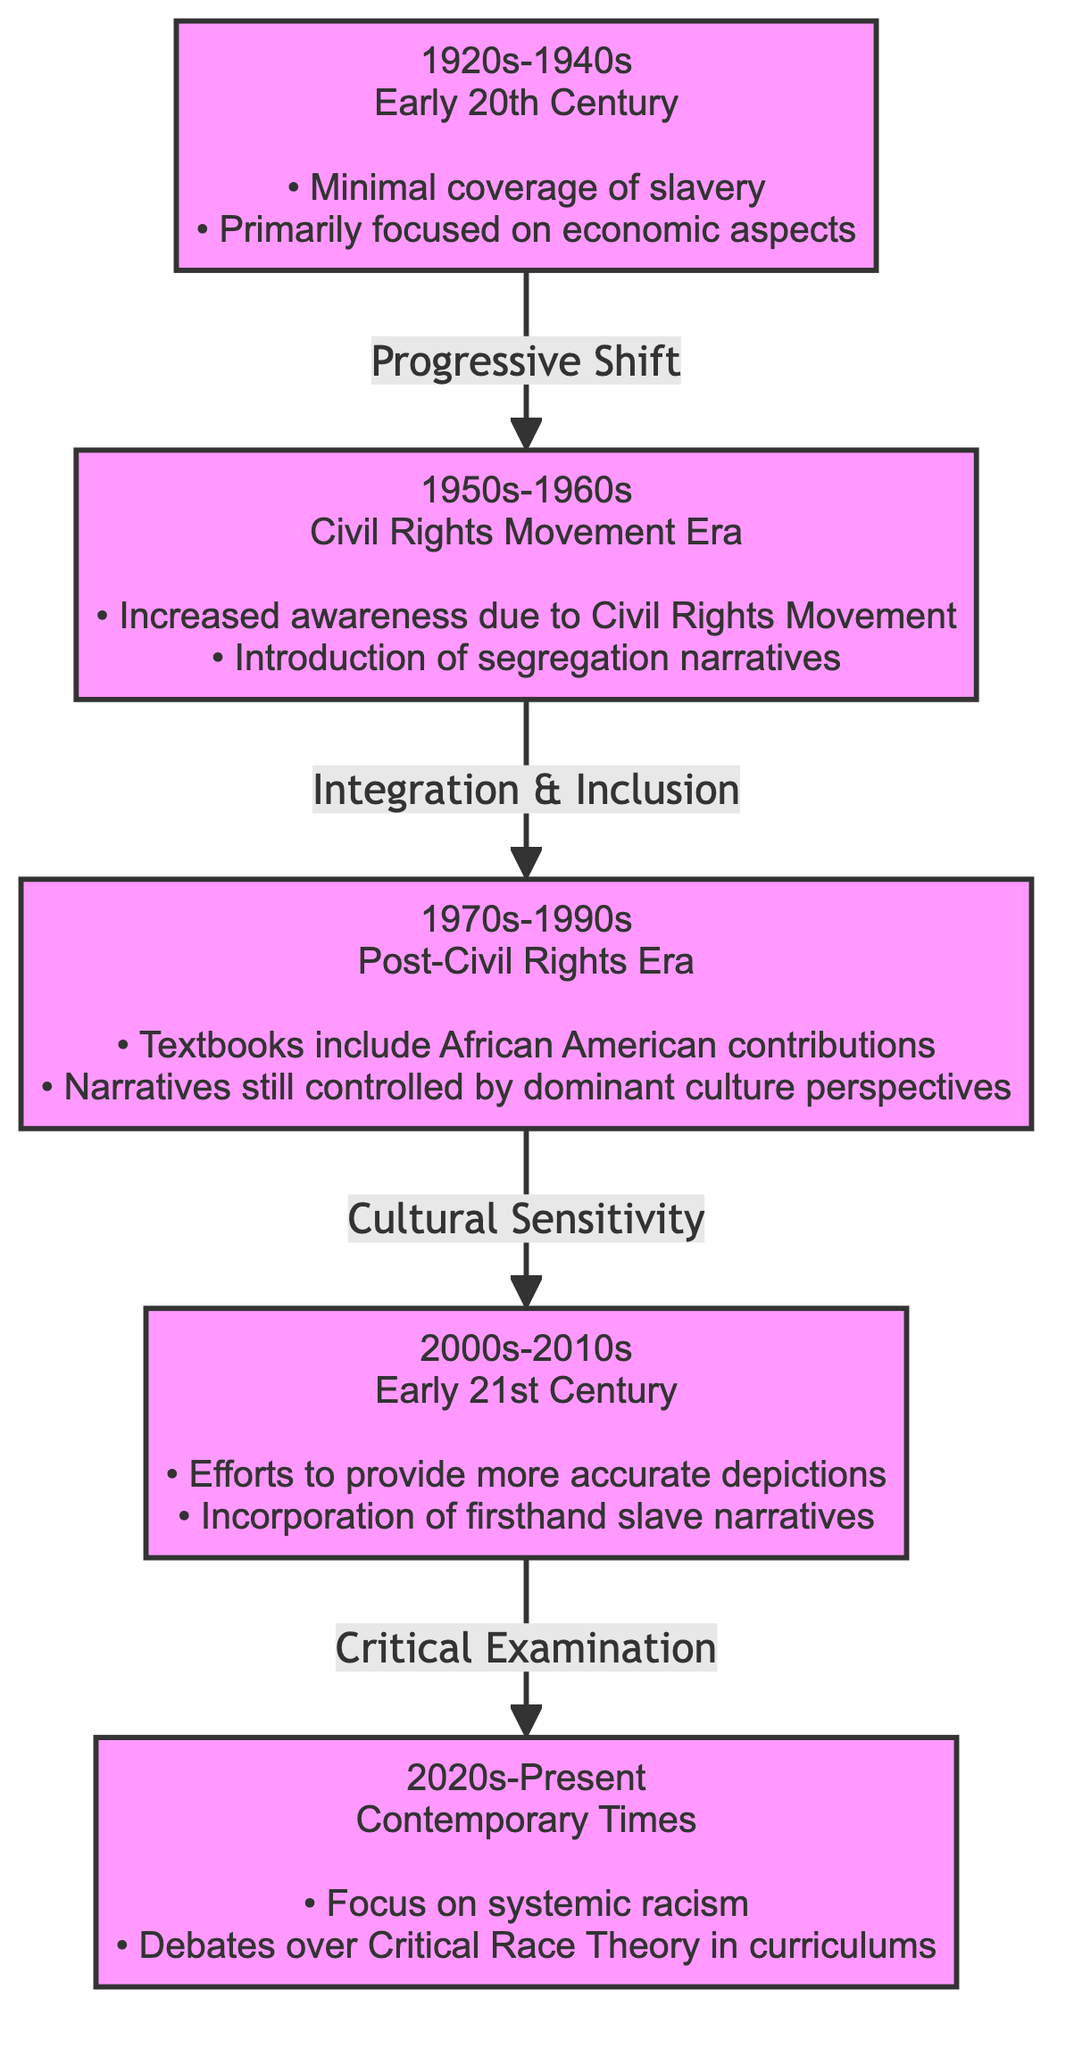What is the first decade represented in the diagram? The diagram starts with the 1920s node, which is the earliest decade mentioned in the evolution of slavery education.
Answer: 1920s How many major time periods are indicated in the diagram? The diagram includes five distinct time periods that are labeled as nodes, representing the evolution of slavery education.
Answer: 5 What shift is identified between the 1920s and the 1950s? The transition from the 1920s node to the 1950s node is marked by a "Progressive Shift," indicating a change in how slavery was addressed in education.
Answer: Progressive Shift Which decades focus on cultural narratives and sensitivity? The 1970s and 2000s both emphasize cultural narratives, as indicated by the labels "Cultural Sensitivity" and "Critical Examination," respectively.
Answer: 1970s, 2000s What aspect of slavery education began to change in the 2000s? The 2000s node notes that efforts were made to provide more accurate depictions of slavery education, reflecting a notable change from previous decades.
Answer: Accurate depictions What is the relationship between the 1950s and 1970s time periods? The relationship indicates 'Integration & Inclusion,' suggesting that the Civil Rights Movement in the 1950s influenced the educational narratives in the 1970s.
Answer: Integration & Inclusion What major social movement influenced the curriculum changes in the 1950s? The Civil Rights Movement is explicitly mentioned as the influencing factor for increased awareness in how slavery was covered in education during the 1950s.
Answer: Civil Rights Movement What contemporary debate is indicated in the 2020s node? The 2020s node discusses debates over Critical Race Theory, highlighting ongoing discussions regarding how slavery and racism are taught in schools today.
Answer: Critical Race Theory 